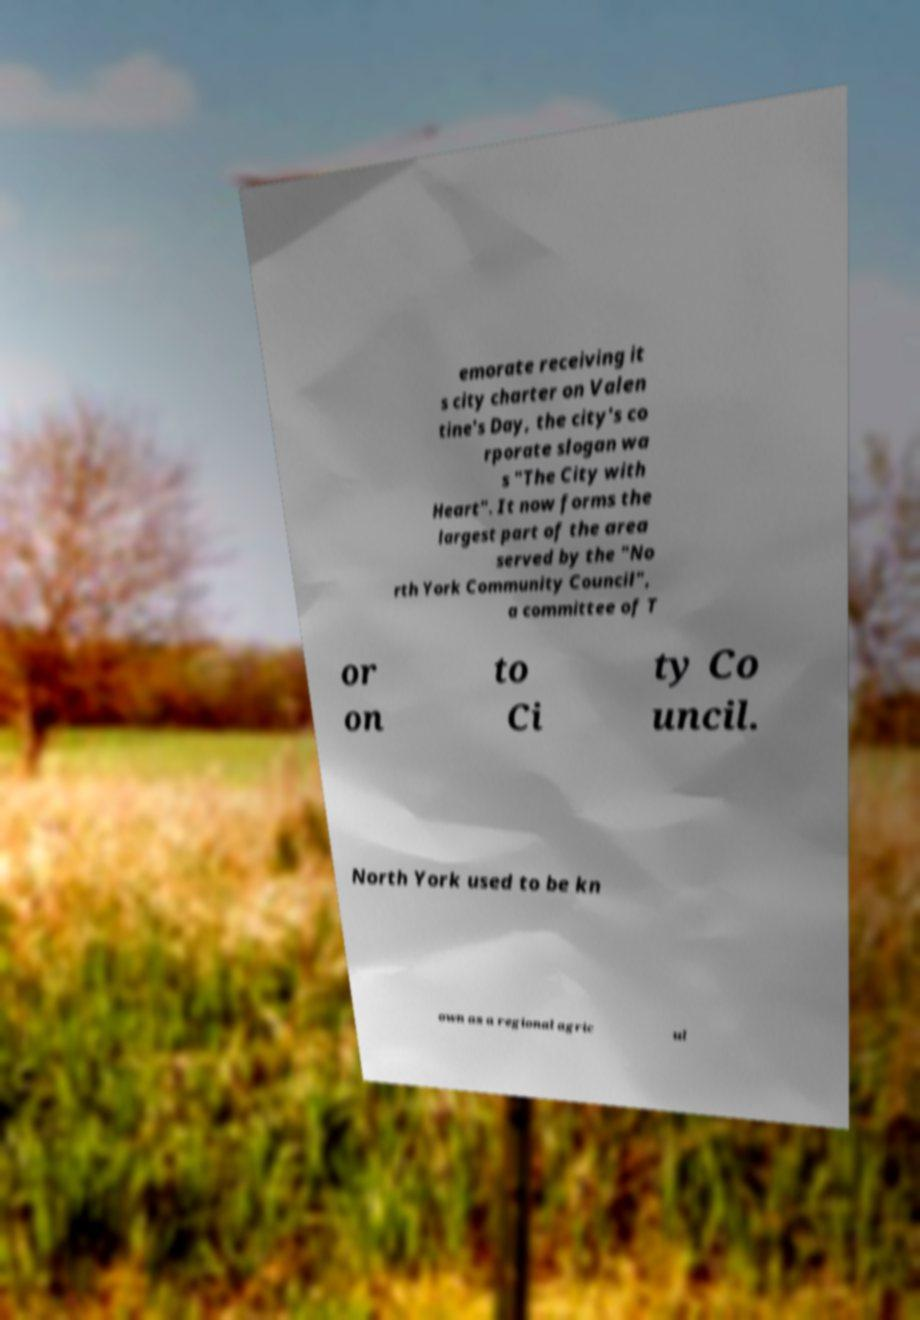Could you extract and type out the text from this image? emorate receiving it s city charter on Valen tine's Day, the city's co rporate slogan wa s "The City with Heart". It now forms the largest part of the area served by the "No rth York Community Council", a committee of T or on to Ci ty Co uncil. North York used to be kn own as a regional agric ul 